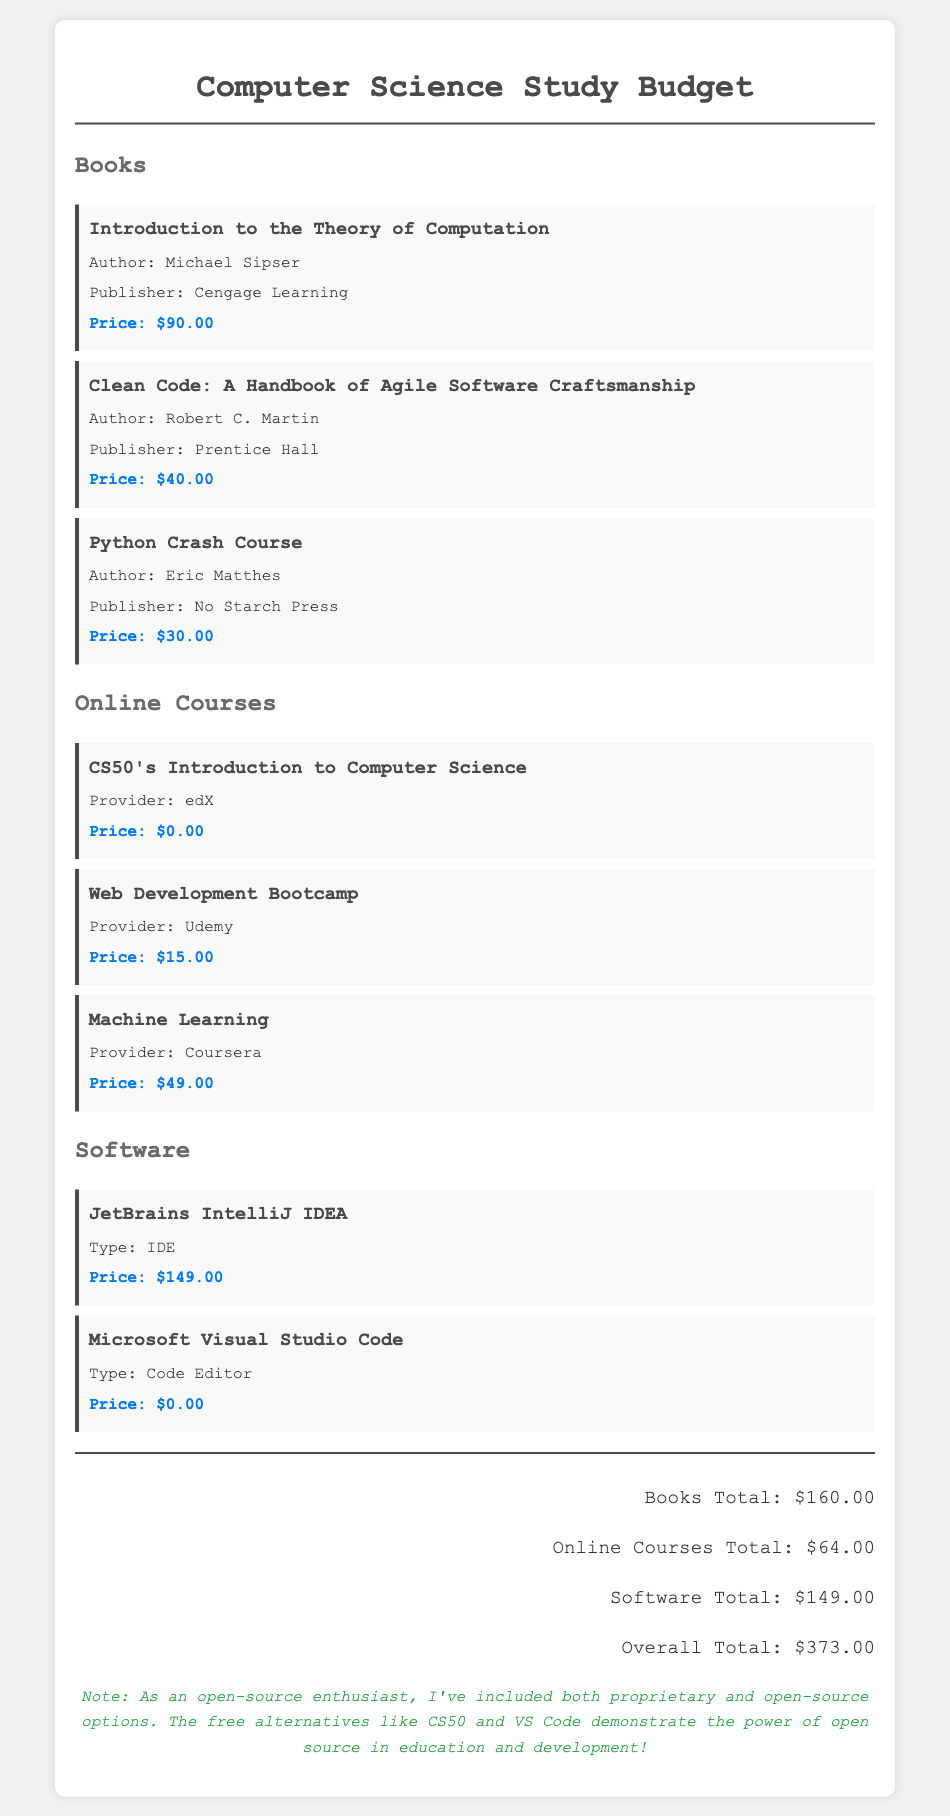What is the price of "Introduction to the Theory of Computation"? The price listed for "Introduction to the Theory of Computation" is $90.00.
Answer: $90.00 Who is the author of "Clean Code"? The author of "Clean Code" is Robert C. Martin.
Answer: Robert C. Martin What is the total cost of books? The total cost of books is calculated from the listed prices of individual books in the document, totaling $160.00.
Answer: $160.00 Which online course is provided by edX? The online course provided by edX is "CS50's Introduction to Computer Science".
Answer: CS50's Introduction to Computer Science What type of software is JetBrains IntelliJ IDEA? JetBrains IntelliJ IDEA is classified as an IDE in the document.
Answer: IDE What is the overall total cost of study materials? The overall total cost is the sum of all categories of expenses listed, which amounts to $373.00.
Answer: $373.00 How much does the Machine Learning course cost? The cost of the Machine Learning course is clearly stated in the document as $49.00.
Answer: $49.00 What is the pricing for Microsoft Visual Studio Code? Microsoft Visual Studio Code is listed as being free at a price of $0.00.
Answer: $0.00 What does the open-source note emphasize? The open-source note emphasizes the inclusion of both proprietary and open-source options in the study materials.
Answer: Inclusion of both proprietary and open-source options 